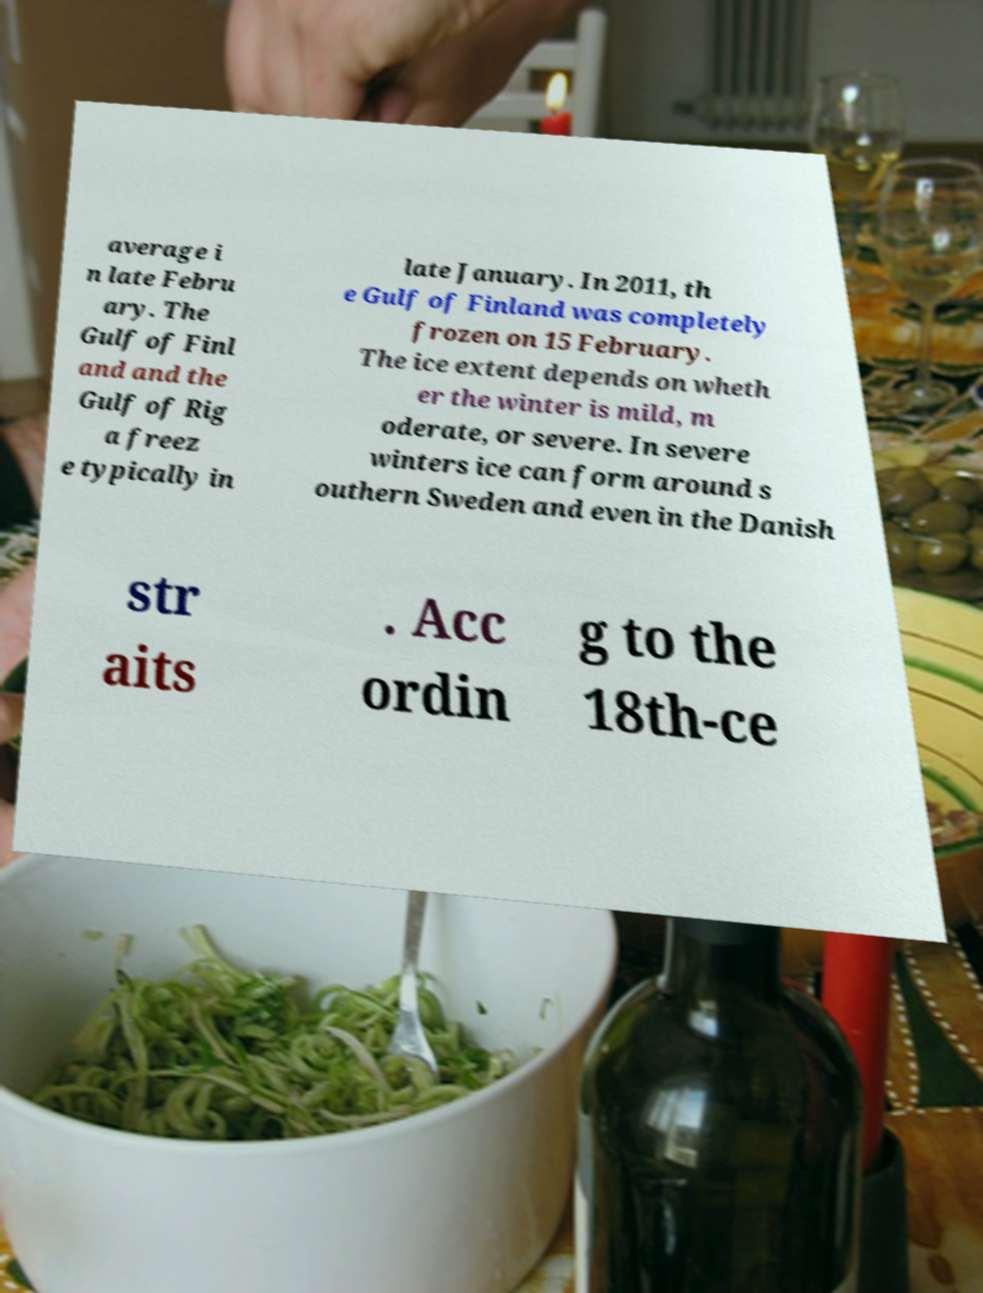Can you read and provide the text displayed in the image?This photo seems to have some interesting text. Can you extract and type it out for me? average i n late Febru ary. The Gulf of Finl and and the Gulf of Rig a freez e typically in late January. In 2011, th e Gulf of Finland was completely frozen on 15 February. The ice extent depends on wheth er the winter is mild, m oderate, or severe. In severe winters ice can form around s outhern Sweden and even in the Danish str aits . Acc ordin g to the 18th-ce 